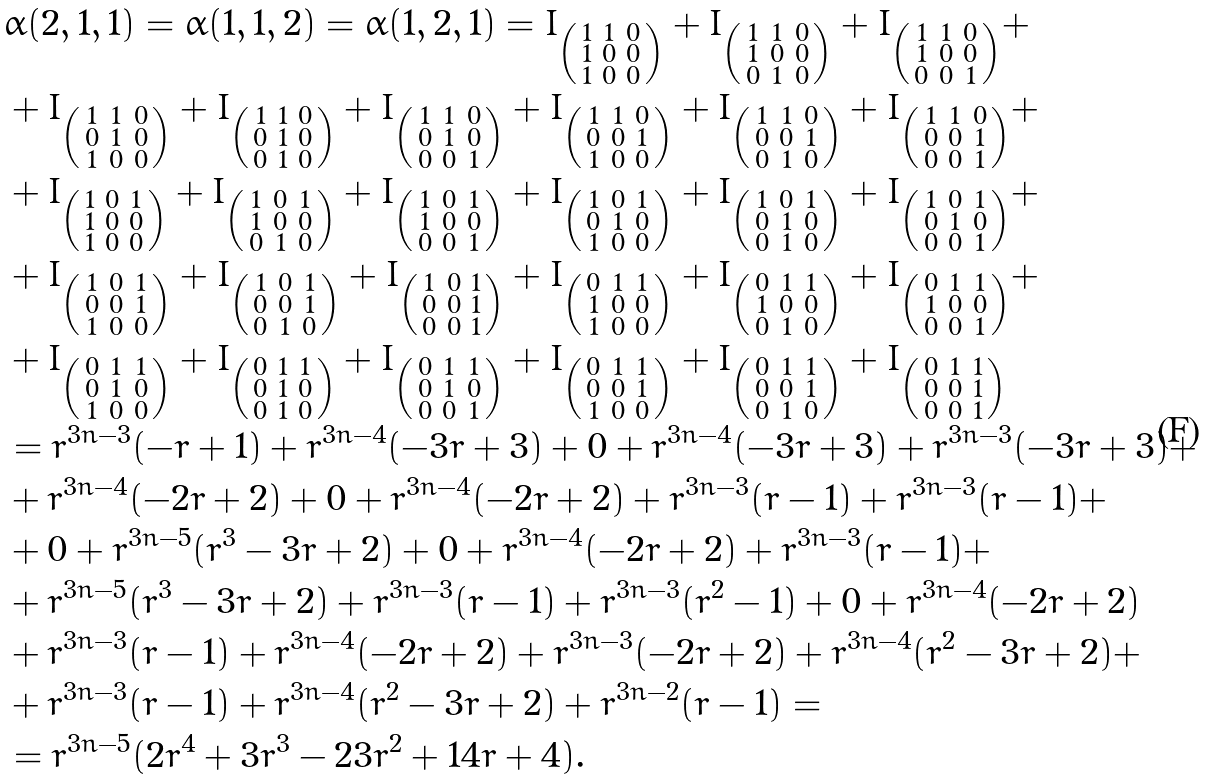<formula> <loc_0><loc_0><loc_500><loc_500>& \alpha ( 2 , 1 , 1 ) = \alpha ( 1 , 1 , 2 ) = \alpha ( 1 , 2 , 1 ) = I _ { \left ( \begin{smallmatrix} 1 & 1 & 0 \\ 1 & 0 & 0 \\ 1 & 0 & 0 \end{smallmatrix} \right ) } + I _ { \left ( \begin{smallmatrix} 1 & 1 & 0 \\ 1 & 0 & 0 \\ 0 & 1 & 0 \end{smallmatrix} \right ) } + I _ { \left ( \begin{smallmatrix} 1 & 1 & 0 \\ 1 & 0 & 0 \\ 0 & 0 & 1 \end{smallmatrix} \right ) } + \\ & + I _ { \left ( \begin{smallmatrix} 1 & 1 & 0 \\ 0 & 1 & 0 \\ 1 & 0 & 0 \end{smallmatrix} \right ) } + I _ { \left ( \begin{smallmatrix} 1 & 1 & 0 \\ 0 & 1 & 0 \\ 0 & 1 & 0 \end{smallmatrix} \right ) } + I _ { \left ( \begin{smallmatrix} 1 & 1 & 0 \\ 0 & 1 & 0 \\ 0 & 0 & 1 \end{smallmatrix} \right ) } + I _ { \left ( \begin{smallmatrix} 1 & 1 & 0 \\ 0 & 0 & 1 \\ 1 & 0 & 0 \end{smallmatrix} \right ) } + I _ { \left ( \begin{smallmatrix} 1 & 1 & 0 \\ 0 & 0 & 1 \\ 0 & 1 & 0 \end{smallmatrix} \right ) } + I _ { \left ( \begin{smallmatrix} 1 & 1 & 0 \\ 0 & 0 & 1 \\ 0 & 0 & 1 \end{smallmatrix} \right ) } + \\ & + I _ { \left ( \begin{smallmatrix} 1 & 0 & 1 \\ 1 & 0 & 0 \\ 1 & 0 & 0 \end{smallmatrix} \right ) } + I _ { \left ( \begin{smallmatrix} 1 & 0 & 1 \\ 1 & 0 & 0 \\ 0 & 1 & 0 \end{smallmatrix} \right ) } + I _ { \left ( \begin{smallmatrix} 1 & 0 & 1 \\ 1 & 0 & 0 \\ 0 & 0 & 1 \end{smallmatrix} \right ) } + I _ { \left ( \begin{smallmatrix} 1 & 0 & 1 \\ 0 & 1 & 0 \\ 1 & 0 & 0 \end{smallmatrix} \right ) } + I _ { \left ( \begin{smallmatrix} 1 & 0 & 1 \\ 0 & 1 & 0 \\ 0 & 1 & 0 \end{smallmatrix} \right ) } + I _ { \left ( \begin{smallmatrix} 1 & 0 & 1 \\ 0 & 1 & 0 \\ 0 & 0 & 1 \end{smallmatrix} \right ) } + \\ & + I _ { \left ( \begin{smallmatrix} 1 & 0 & 1 \\ 0 & 0 & 1 \\ 1 & 0 & 0 \end{smallmatrix} \right ) } + I _ { \left ( \begin{smallmatrix} 1 & 0 & 1 \\ 0 & 0 & 1 \\ 0 & 1 & 0 \end{smallmatrix} \right ) } + I _ { \left ( \begin{smallmatrix} 1 & 0 & 1 \\ 0 & 0 & 1 \\ 0 & 0 & 1 \end{smallmatrix} \right ) } + I _ { \left ( \begin{smallmatrix} 0 & 1 & 1 \\ 1 & 0 & 0 \\ 1 & 0 & 0 \end{smallmatrix} \right ) } + I _ { \left ( \begin{smallmatrix} 0 & 1 & 1 \\ 1 & 0 & 0 \\ 0 & 1 & 0 \end{smallmatrix} \right ) } + I _ { \left ( \begin{smallmatrix} 0 & 1 & 1 \\ 1 & 0 & 0 \\ 0 & 0 & 1 \end{smallmatrix} \right ) } + \\ & + I _ { \left ( \begin{smallmatrix} 0 & 1 & 1 \\ 0 & 1 & 0 \\ 1 & 0 & 0 \end{smallmatrix} \right ) } + I _ { \left ( \begin{smallmatrix} 0 & 1 & 1 \\ 0 & 1 & 0 \\ 0 & 1 & 0 \end{smallmatrix} \right ) } + I _ { \left ( \begin{smallmatrix} 0 & 1 & 1 \\ 0 & 1 & 0 \\ 0 & 0 & 1 \end{smallmatrix} \right ) } + I _ { \left ( \begin{smallmatrix} 0 & 1 & 1 \\ 0 & 0 & 1 \\ 1 & 0 & 0 \end{smallmatrix} \right ) } + I _ { \left ( \begin{smallmatrix} 0 & 1 & 1 \\ 0 & 0 & 1 \\ 0 & 1 & 0 \end{smallmatrix} \right ) } + I _ { \left ( \begin{smallmatrix} 0 & 1 & 1 \\ 0 & 0 & 1 \\ 0 & 0 & 1 \end{smallmatrix} \right ) } \\ & = r ^ { 3 n - 3 } ( - r + 1 ) + r ^ { 3 n - 4 } ( - 3 r + 3 ) + 0 + r ^ { 3 n - 4 } ( - 3 r + 3 ) + r ^ { 3 n - 3 } ( - 3 r + 3 ) + \\ & + r ^ { 3 n - 4 } ( - 2 r + 2 ) + 0 + r ^ { 3 n - 4 } ( - 2 r + 2 ) + r ^ { 3 n - 3 } ( r - 1 ) + r ^ { 3 n - 3 } ( r - 1 ) + \\ & + 0 + r ^ { 3 n - 5 } ( r ^ { 3 } - 3 r + 2 ) + 0 + r ^ { 3 n - 4 } ( - 2 r + 2 ) + r ^ { 3 n - 3 } ( r - 1 ) + \\ & + r ^ { 3 n - 5 } ( r ^ { 3 } - 3 r + 2 ) + r ^ { 3 n - 3 } ( r - 1 ) + r ^ { 3 n - 3 } ( r ^ { 2 } - 1 ) + 0 + r ^ { 3 n - 4 } ( - 2 r + 2 ) \\ & + r ^ { 3 n - 3 } ( r - 1 ) + r ^ { 3 n - 4 } ( - 2 r + 2 ) + r ^ { 3 n - 3 } ( - 2 r + 2 ) + r ^ { 3 n - 4 } ( r ^ { 2 } - 3 r + 2 ) + \\ & + r ^ { 3 n - 3 } ( r - 1 ) + r ^ { 3 n - 4 } ( r ^ { 2 } - 3 r + 2 ) + r ^ { 3 n - 2 } ( r - 1 ) = \\ & = r ^ { 3 n - 5 } ( 2 r ^ { 4 } + 3 r ^ { 3 } - 2 3 r ^ { 2 } + 1 4 r + 4 ) .</formula> 